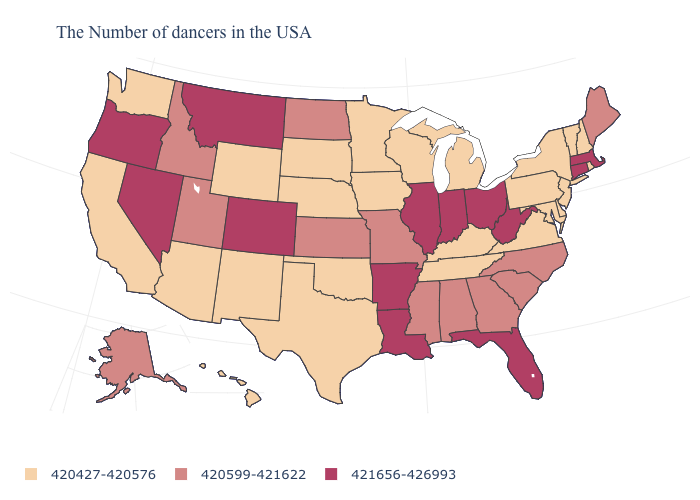How many symbols are there in the legend?
Answer briefly. 3. How many symbols are there in the legend?
Give a very brief answer. 3. Which states have the highest value in the USA?
Give a very brief answer. Massachusetts, Connecticut, West Virginia, Ohio, Florida, Indiana, Illinois, Louisiana, Arkansas, Colorado, Montana, Nevada, Oregon. Does Virginia have the same value as Montana?
Concise answer only. No. What is the value of Michigan?
Be succinct. 420427-420576. What is the value of Alaska?
Quick response, please. 420599-421622. What is the value of Tennessee?
Keep it brief. 420427-420576. Which states have the lowest value in the USA?
Be succinct. Rhode Island, New Hampshire, Vermont, New York, New Jersey, Delaware, Maryland, Pennsylvania, Virginia, Michigan, Kentucky, Tennessee, Wisconsin, Minnesota, Iowa, Nebraska, Oklahoma, Texas, South Dakota, Wyoming, New Mexico, Arizona, California, Washington, Hawaii. Name the states that have a value in the range 420427-420576?
Answer briefly. Rhode Island, New Hampshire, Vermont, New York, New Jersey, Delaware, Maryland, Pennsylvania, Virginia, Michigan, Kentucky, Tennessee, Wisconsin, Minnesota, Iowa, Nebraska, Oklahoma, Texas, South Dakota, Wyoming, New Mexico, Arizona, California, Washington, Hawaii. Name the states that have a value in the range 420599-421622?
Answer briefly. Maine, North Carolina, South Carolina, Georgia, Alabama, Mississippi, Missouri, Kansas, North Dakota, Utah, Idaho, Alaska. What is the value of North Dakota?
Quick response, please. 420599-421622. Name the states that have a value in the range 420599-421622?
Keep it brief. Maine, North Carolina, South Carolina, Georgia, Alabama, Mississippi, Missouri, Kansas, North Dakota, Utah, Idaho, Alaska. Among the states that border Wyoming , does Colorado have the highest value?
Quick response, please. Yes. Among the states that border Tennessee , which have the highest value?
Answer briefly. Arkansas. 